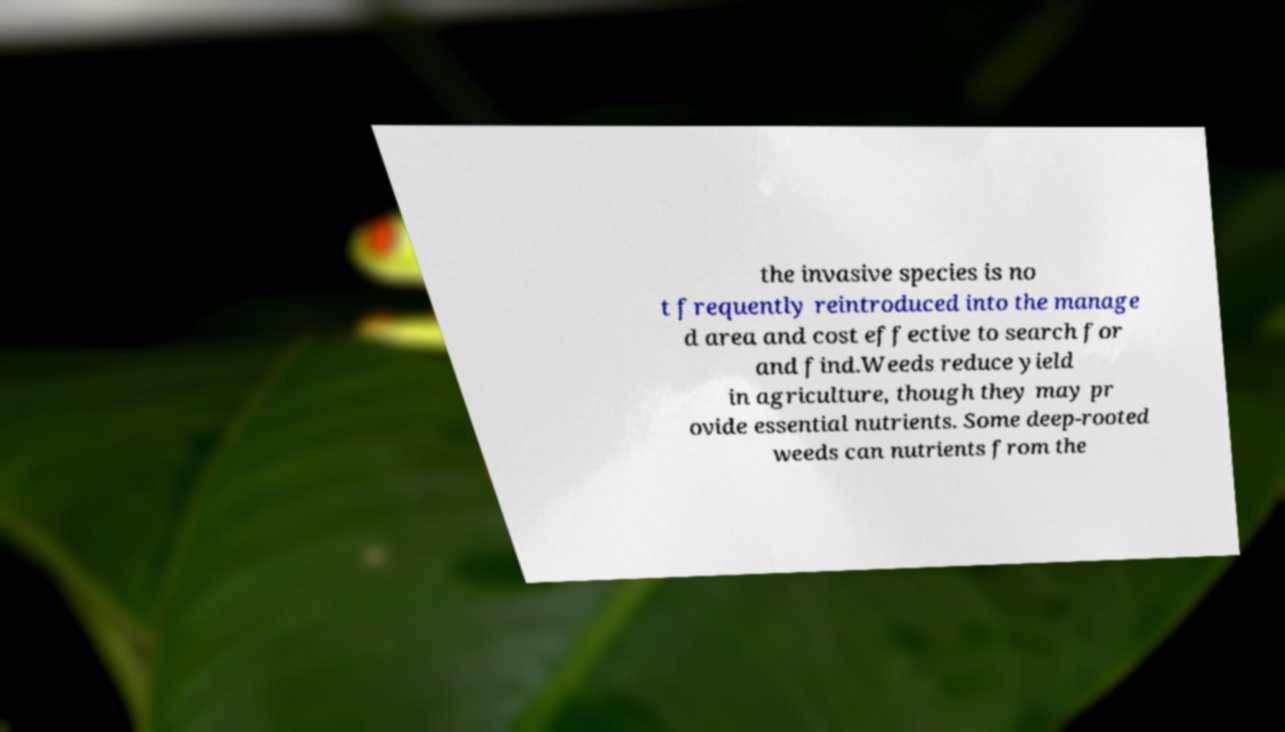What messages or text are displayed in this image? I need them in a readable, typed format. the invasive species is no t frequently reintroduced into the manage d area and cost effective to search for and find.Weeds reduce yield in agriculture, though they may pr ovide essential nutrients. Some deep-rooted weeds can nutrients from the 